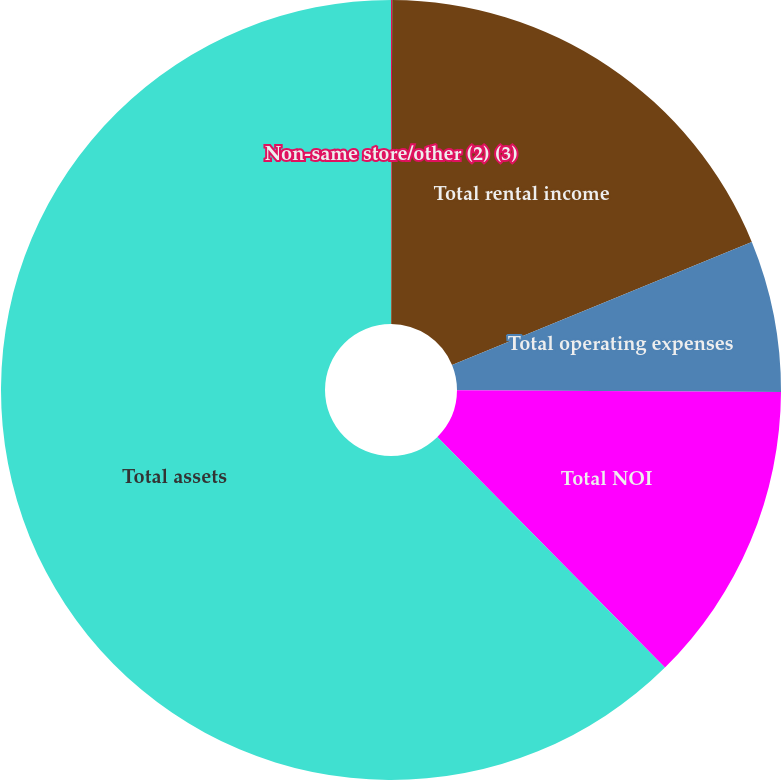<chart> <loc_0><loc_0><loc_500><loc_500><pie_chart><fcel>Non-same store/other (2) (3)<fcel>Total rental income<fcel>Total operating expenses<fcel>Total NOI<fcel>Total assets<nl><fcel>0.05%<fcel>18.75%<fcel>6.28%<fcel>12.52%<fcel>62.39%<nl></chart> 